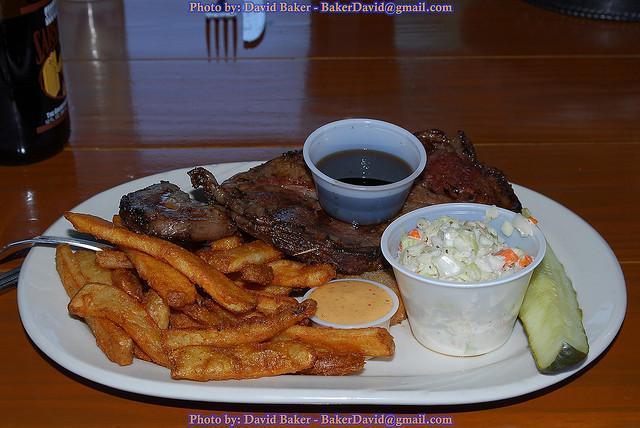How many forks are on the table?
Give a very brief answer. 1. How many cups are in the photo?
Give a very brief answer. 2. How many people are walking?
Give a very brief answer. 0. 